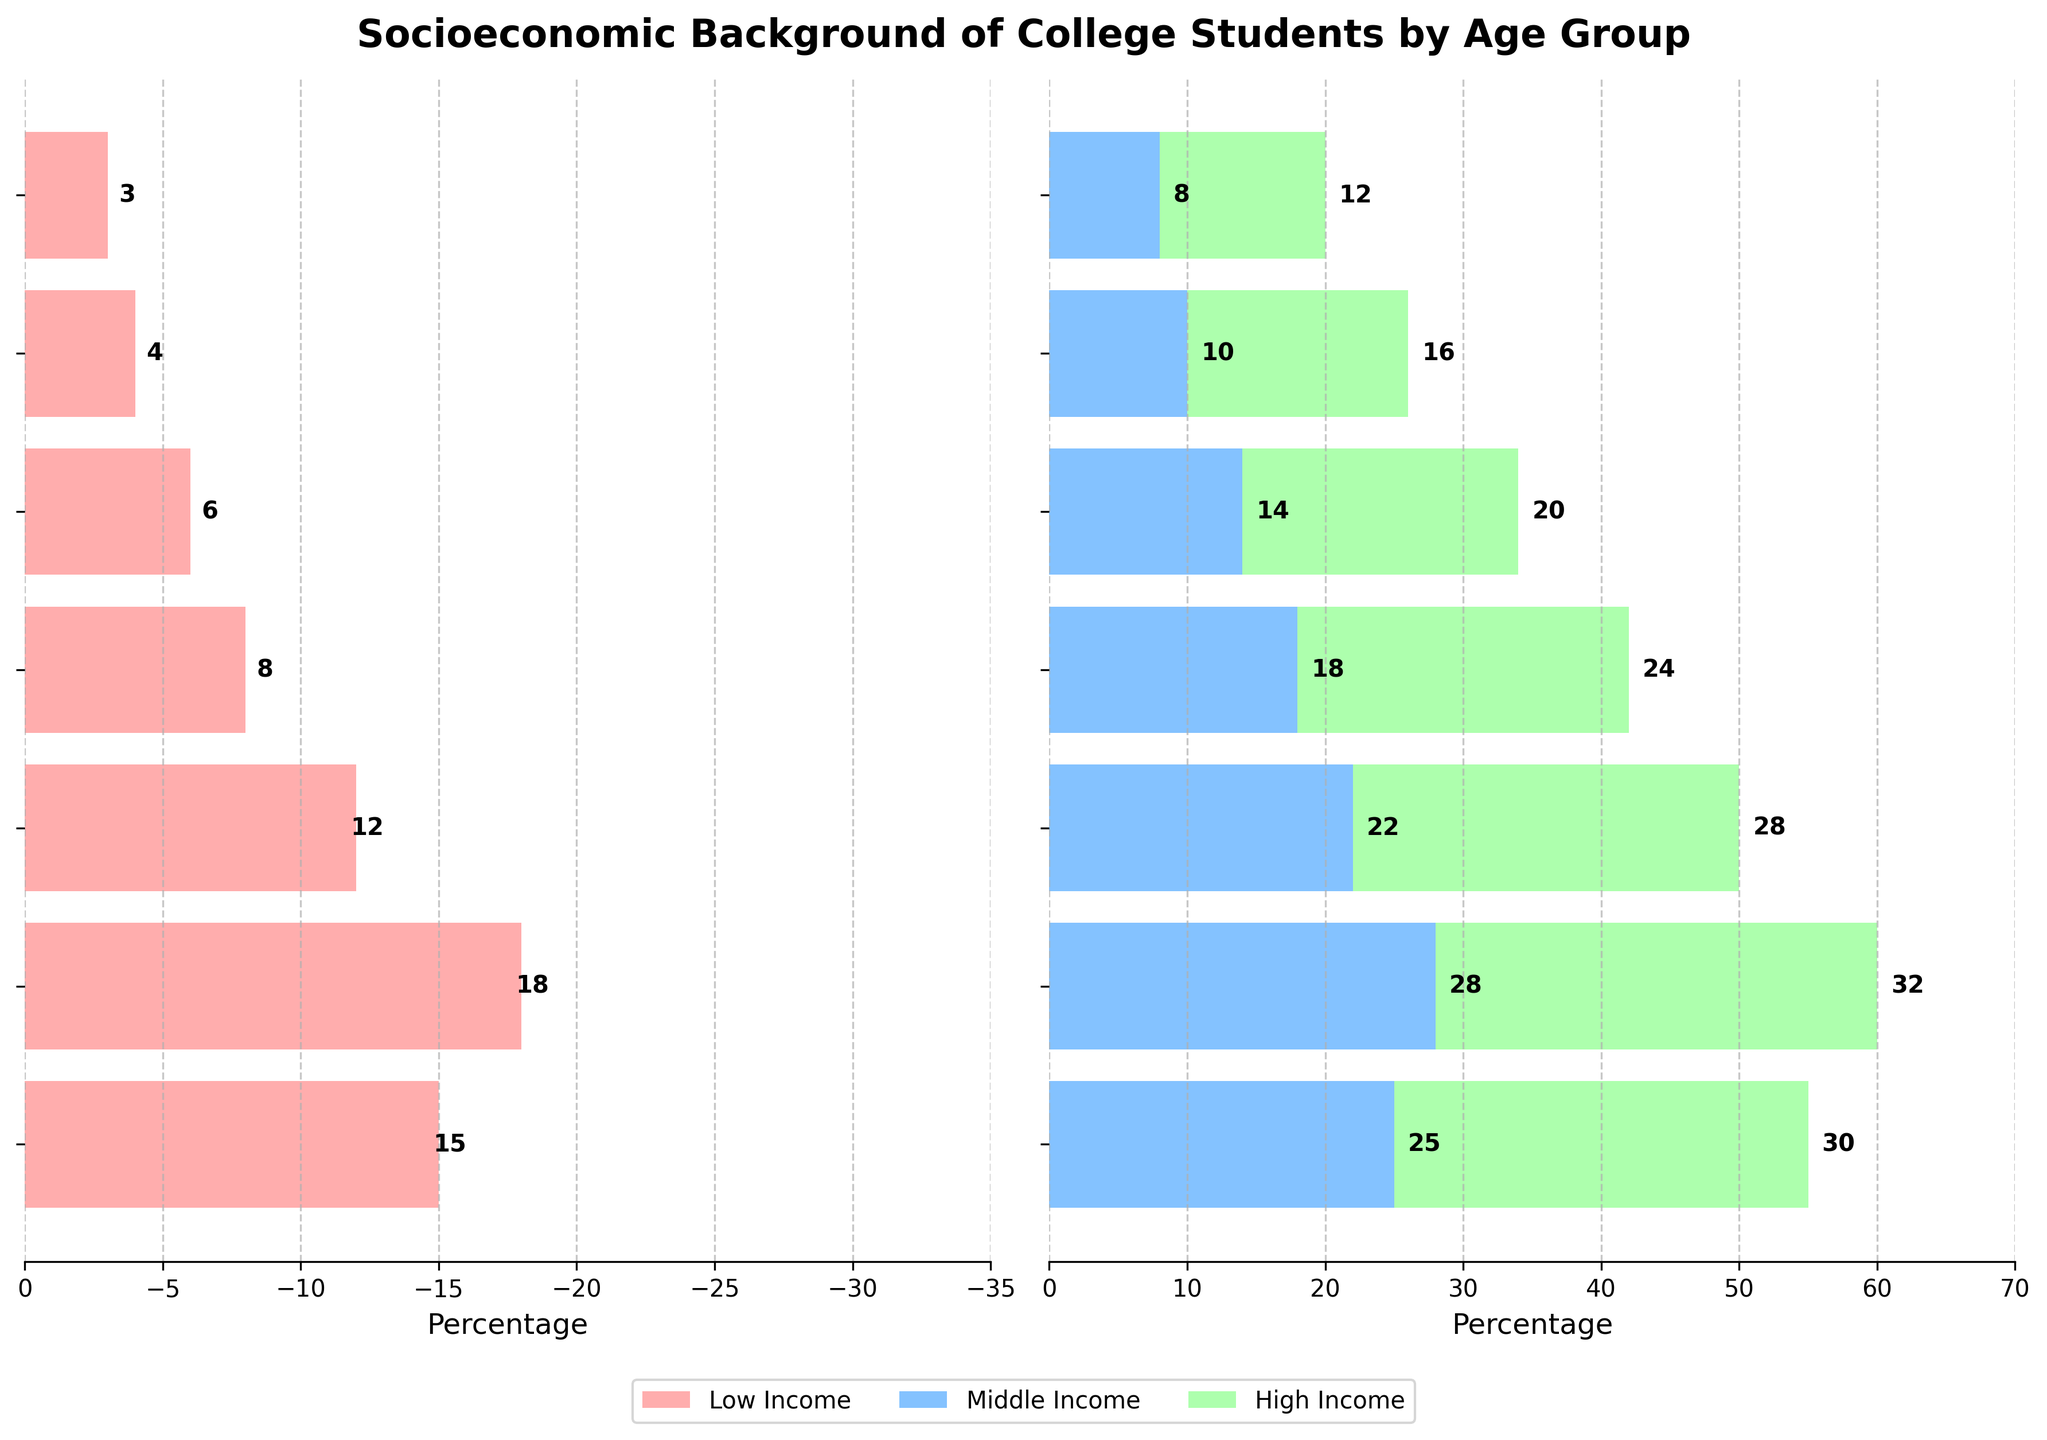What is the title of the figure? The title of the figure is displayed at the top. It states 'Socioeconomic Background of College Students by Age Group'.
Answer: Socioeconomic Background of College Students by Age Group What age group has the highest proportion of students from high-income backgrounds? The age group with the highest proportion of high-income students is indicated by the longest green bar on the right side of the pyramid. This corresponds to the age group '21-23'.
Answer: 21-23 What is the total percentage of low-income students in the age group 24-26? The percentage of low-income students in the age group 24-26 can be directly observed from the length of the red bar on the left side for this age group. The bar reaches 12%.
Answer: 12% Which age group has the smallest number of students from middle-income backgrounds? The age group with the smallest number of middle-income students can be identified by the shortest blue bar on the right side of the pyramid. This corresponds to the age group '36+'.
Answer: 36+ Compare the number of high-income students in the age groups 18-20 and 30-32. Which group has a higher number of high-income students and by how much? The high-income numbers are represented by the green bars. The age group '18-20' has 30 high-income students, and '30-32' has 20 high-income students. The group '18-20' has 10 more high-income students than '30-32'.
Answer: 18-20 has 10 more students What is the combined total percentage of low-income and high-income students in the age group 27-29? For the age group 27-29, the low-income percentage is 8%, and the high-income percentage is 24%. Adding these percentages gives us 8% + 24% = 32%.
Answer: 32% Is there any age group where the number of middle-income students is exactly double the number of low-income students? By checking each age group's bars, we see that for ages 21-23, the low-income students are 18, and middle-income students are 28, which is not double. For 27-29, the low-income students are 8, and the middle-income students are 18. None of the groups fit the double criteria exactly.
Answer: No Which age group has the most balanced distribution among the three income categories? The most balanced distribution is observed by comparing the length of the bars for each group. The more even the bars, the more balanced the distribution. The age group '24-26' has relatively balanced values of 12, 22, and 28, though not perfectly equal.
Answer: 24-26 In the age group 33-35, what is the difference in the number of high-income and low-income students? The number of high-income students in the age group 33-35 is 16, and the number of low-income students is 4. The difference is 16 - 4 = 12 students.
Answer: 12 students How does the percentage of middle-income students change from the age group 18-20 to the age group 36+? The percentage for the middle-income group decreases from 25% (age group 18-20) to 8% (age group 36+). This corresponds to a 17% decrease.
Answer: Decreases by 17% 